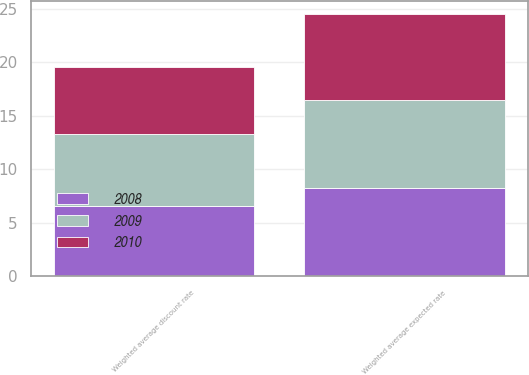<chart> <loc_0><loc_0><loc_500><loc_500><stacked_bar_chart><ecel><fcel>Weighted average discount rate<fcel>Weighted average expected rate<nl><fcel>2010<fcel>6.25<fcel>8<nl><fcel>2008<fcel>6.6<fcel>8.25<nl><fcel>2009<fcel>6.65<fcel>8.25<nl></chart> 